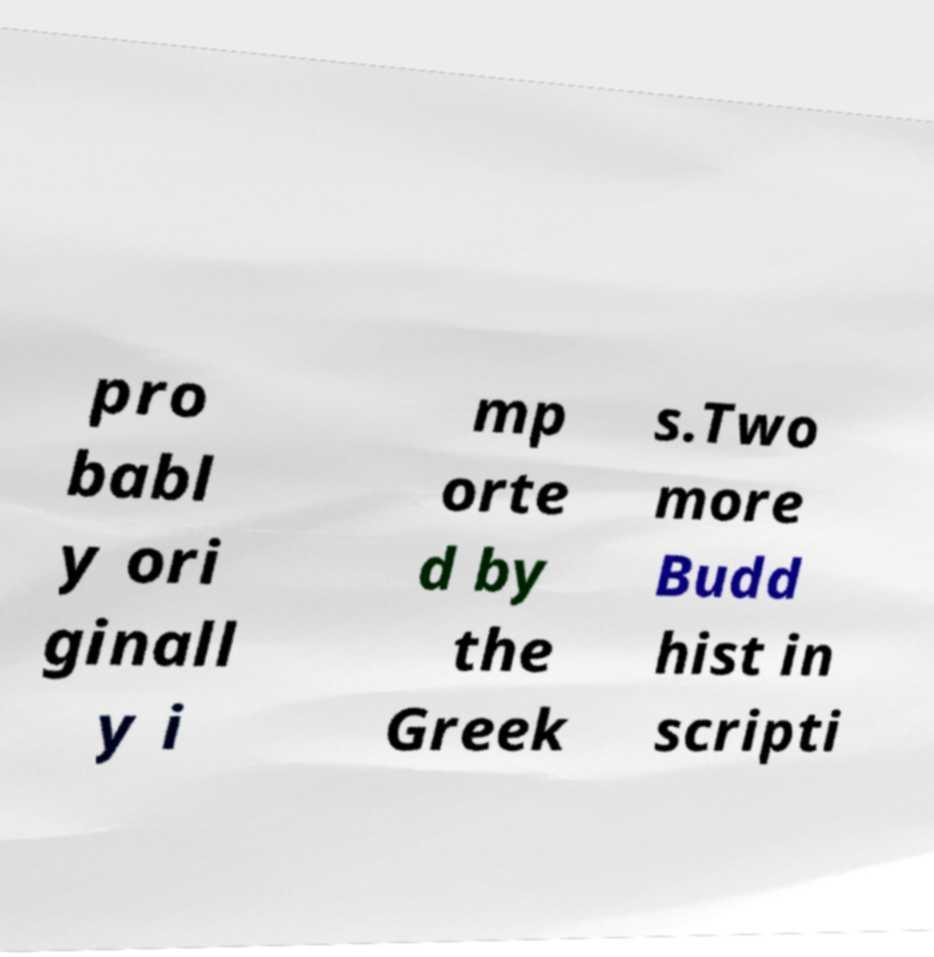I need the written content from this picture converted into text. Can you do that? pro babl y ori ginall y i mp orte d by the Greek s.Two more Budd hist in scripti 